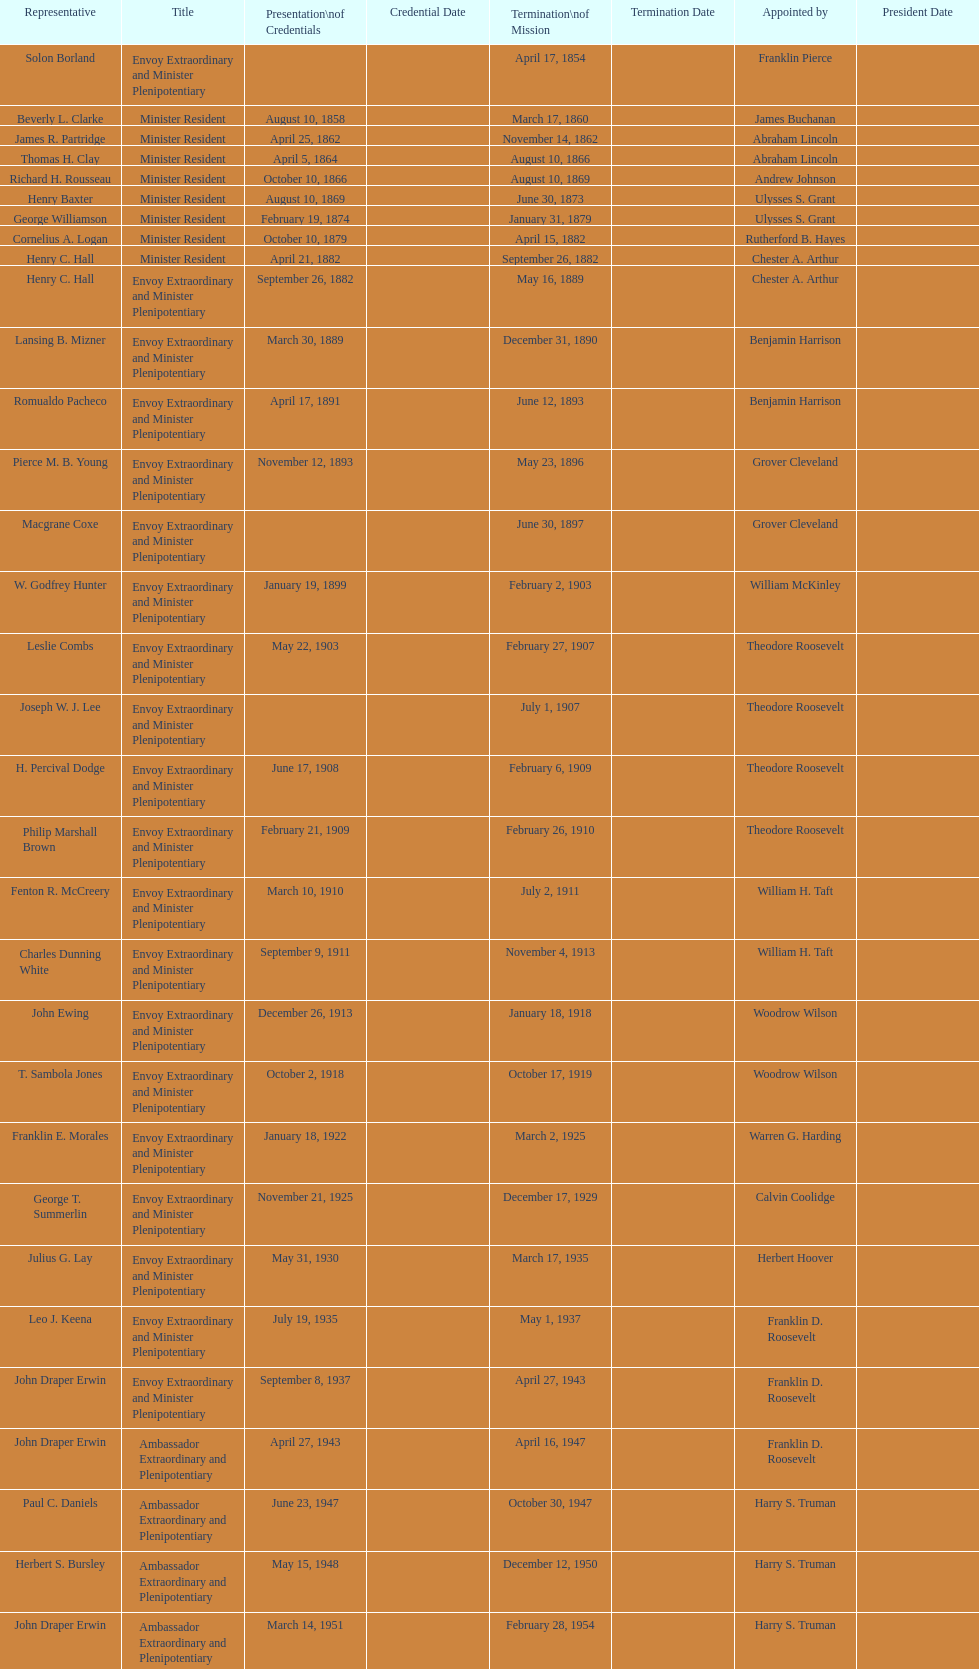Which date comes before april 17, 1854? March 17, 1860. 